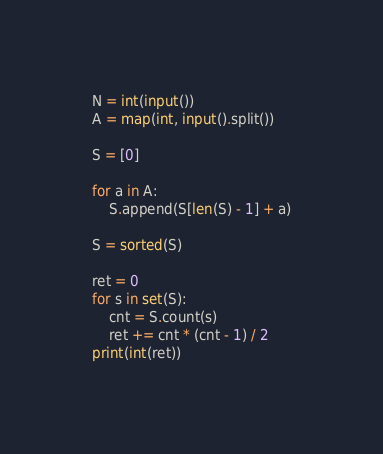<code> <loc_0><loc_0><loc_500><loc_500><_Python_>N = int(input())
A = map(int, input().split())

S = [0]

for a in A:
    S.append(S[len(S) - 1] + a)

S = sorted(S)

ret = 0
for s in set(S):
    cnt = S.count(s)
    ret += cnt * (cnt - 1) / 2
print(int(ret))
</code> 